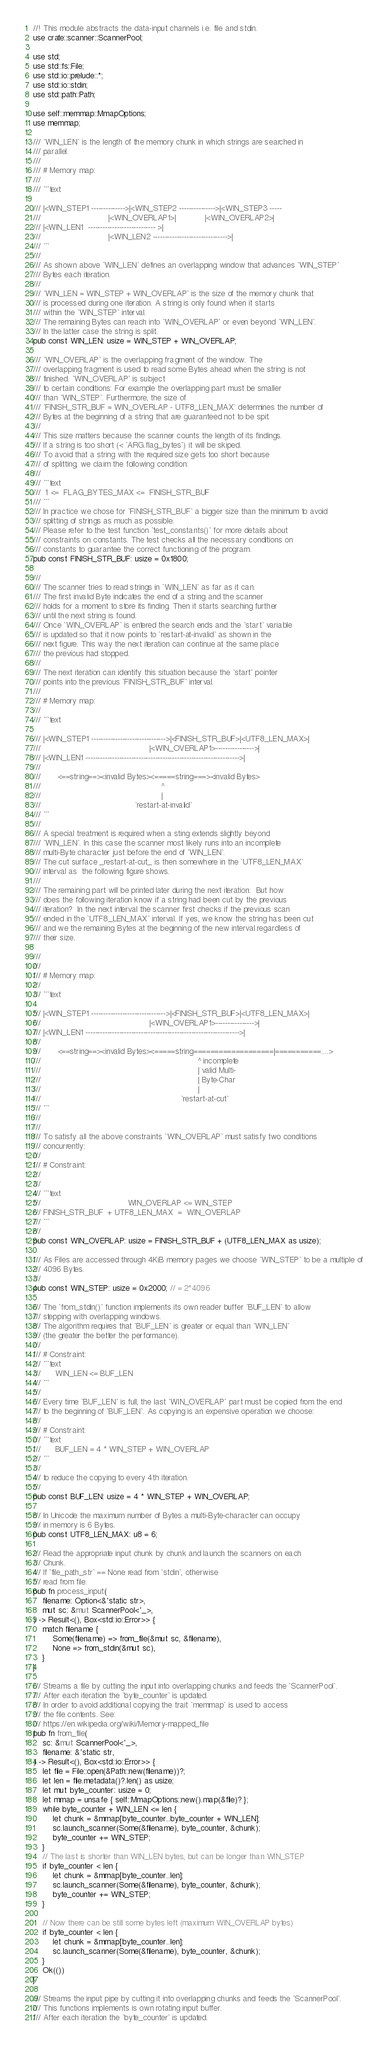<code> <loc_0><loc_0><loc_500><loc_500><_Rust_>//! This module abstracts the data-input channels i.e. file and stdin.
use crate::scanner::ScannerPool;

use std;
use std::fs::File;
use std::io::prelude::*;
use std::io::stdin;
use std::path::Path;

use self::memmap::MmapOptions;
use memmap;

/// `WIN_LEN` is the length of the memory chunk in which strings are searched in
/// parallel.
///
/// # Memory map:
///
/// ```text

/// |<WIN_STEP1 -------------->|<WIN_STEP2 --------------->|<WIN_STEP3 -----
///                            |<WIN_OVERLAP1>|            |<WIN_OVERLAP2>|
/// |<WIN_LEN1  ---------------------------- >|
///                            |<WIN_LEN2 ------------------------------->|
/// ```
///
/// As shown above `WIN_LEN` defines an overlapping window that advances `WIN_STEP`
/// Bytes each iteration.
///
/// `WIN_LEN = WIN_STEP + WIN_OVERLAP` is the size of the memory chunk that
/// is processed during one iteration. A string is only found when it starts
/// within the `WIN_STEP` interval.
/// The remaining Bytes can reach into `WIN_OVERLAP` or even beyond `WIN_LEN`.
/// In the latter case the string is split.
pub const WIN_LEN: usize = WIN_STEP + WIN_OVERLAP;

/// `WIN_OVERLAP` is the overlapping fragment of the window. The
/// overlapping fragment is used to read some Bytes ahead when the string is not
/// finished. `WIN_OVERLAP` is subject
/// to certain conditions: For example the overlapping part must be smaller
/// than `WIN_STEP`. Furthermore, the size of
/// `FINISH_STR_BUF = WIN_OVERLAP - UTF8_LEN_MAX` determines the number of
/// Bytes at the beginning of a string that are guaranteed not to be spit.
///
/// This size matters because the scanner counts the length of its findings.
/// If a string is too short (< `ARG.flag_bytes`) it will be skiped.
/// To avoid that a string with the required size gets too short because
/// of splitting, we claim the following condition:
///
/// ```text
///  1 <=  FLAG_BYTES_MAX <=  FINISH_STR_BUF
/// ```
/// In practice we chose for `FINISH_STR_BUF` a bigger size than the minimum to avoid
/// splitting of strings as much as possible.
/// Please refer to the test function `test_constants()` for more details about
/// constraints on constants. The test checks all the necessary conditions on
/// constants to guarantee the correct functioning of the program.
pub const FINISH_STR_BUF: usize = 0x1800;

///
/// The scanner tries to read strings in `WIN_LEN` as far as it can.
/// The first invalid Byte indicates the end of a string and the scanner
/// holds for a moment to store its finding. Then it starts searching further
/// until the next string is found.
/// Once `WIN_OVERLAP` is entered the search ends and the `start` variable
/// is updated so that it now points to `restart-at-invalid` as shown in the
/// next figure. This way the next iteration can continue at the same place
/// the previous had stopped.
///
/// The next iteration can identify this situation because the `start` pointer
/// points into the previous `FINISH_STR_BUF` interval.
///
/// # Memory map:
///
/// ```text

/// |<WIN_STEP1 ------------------------------->|<FINISH_STR_BUF>|<UTF8_LEN_MAX>|
///                                             |<WIN_OVERLAP1>---------------->|
/// |<WIN_LEN1 ---------------------------------------------------------------->|
///
///       <==string==><invalid Bytes><=====string===><invalid Bytes>
///                                                  ^
///                                                  |
///                                       `restart-at-invalid`
/// ```
///
/// A special treatment is required when a sting extends slightly beyond
/// `WIN_LEN`. In this case the scanner most likely runs into an incomplete
/// multi-Byte character just before the end of `WIN_LEN`.
/// The cut surface _restart-at-cut_ is then somewhere in the `UTF8_LEN_MAX`
/// interval as  the following figure shows.
///
/// The remaining part will be printed later during the next iteration.  But how
/// does the following iteration know if a string had been cut by the previous
/// iteration?  In the next interval the scanner first checks if the previous scan
/// ended in the `UTF8_LEN_MAX` interval. If yes, we know the string has been cut
/// and we the remaining Bytes at the beginning of the new interval regardless of
/// their size.

///
///
/// # Memory map:
///
/// ```text

/// |<WIN_STEP1 ------------------------------->|<FINISH_STR_BUF>|<UTF8_LEN_MAX>|
///                                             |<WIN_OVERLAP1>---------------->|
/// |<WIN_LEN1 ---------------------------------------------------------------->|
///
///       <==string==><invalid Bytes><=====string===================|===========....>
///                                                                 ^ incomplete
///                                                                 | valid Multi-
///                                                                 | Byte-Char
///                                                                 |
///                                                          `restart-at-cut`
/// ```
///
///
/// To satisfy all the above constraints `WIN_OVERLAP` must satisfy two conditions
/// concurrently:
///
/// # Constraint:
///
///
/// ```text
///                                    WIN_OVERLAP <= WIN_STEP
/// FINISH_STR_BUF  + UTF8_LEN_MAX  =  WIN_OVERLAP
/// ```
///
pub const WIN_OVERLAP: usize = FINISH_STR_BUF + (UTF8_LEN_MAX as usize);

/// As Files are accessed through 4KiB memory pages we choose `WIN_STEP` to be a multiple of
/// 4096 Bytes.
///
pub const WIN_STEP: usize = 0x2000; // = 2*4096

/// The `from_stdin()` function implements its own reader buffer `BUF_LEN` to allow
/// stepping with overlapping windows.
/// The algorithm requires that `BUF_LEN` is greater or equal than `WIN_LEN`
/// (the greater the better the performance).
///
/// # Constraint:
/// ```text
///      WIN_LEN <= BUF_LEN
/// ```
///
/// Every time `BUF_LEN` is full, the last `WIN_OVERLAP` part must be copied from the end
/// to the beginning of `BUF_LEN`. As copying is an expensive operation we choose:
///
/// # Constraint:
/// ```text
///      BUF_LEN = 4 * WIN_STEP + WIN_OVERLAP
/// ```
///
/// to reduce the copying to every 4th iteration.
///
pub const BUF_LEN: usize = 4 * WIN_STEP + WIN_OVERLAP;

/// In Unicode the maximum number of Bytes a multi-Byte-character can occupy
/// in memory is 6 Bytes.
pub const UTF8_LEN_MAX: u8 = 6;

/// Read the appropriate input chunk by chunk and launch the scanners on each
/// Chunk.
/// If `file_path_str` == None read from `stdin`, otherwise
/// read from file.
pub fn process_input(
    filename: Option<&'static str>,
    mut sc: &mut ScannerPool<'_>,
) -> Result<(), Box<std::io::Error>> {
    match filename {
        Some(filename) => from_file(&mut sc, &filename),
        None => from_stdin(&mut sc),
    }
}

/// Streams a file by cutting the input into overlapping chunks and feeds the `ScannerPool`.
/// After each iteration the `byte_counter` is updated.
/// In order to avoid additional copying the trait `memmap` is used to access
/// the file contents. See:
/// https://en.wikipedia.org/wiki/Memory-mapped_file
pub fn from_file(
    sc: &mut ScannerPool<'_>,
    filename: &'static str,
) -> Result<(), Box<std::io::Error>> {
    let file = File::open(&Path::new(filename))?;
    let len = file.metadata()?.len() as usize;
    let mut byte_counter: usize = 0;
    let mmap = unsafe { self::MmapOptions::new().map(&file)? };
    while byte_counter + WIN_LEN <= len {
        let chunk = &mmap[byte_counter..byte_counter + WIN_LEN];
        sc.launch_scanner(Some(&filename), byte_counter, &chunk);
        byte_counter += WIN_STEP;
    }
    // The last is shorter than WIN_LEN bytes, but can be longer than WIN_STEP
    if byte_counter < len {
        let chunk = &mmap[byte_counter..len];
        sc.launch_scanner(Some(&filename), byte_counter, &chunk);
        byte_counter += WIN_STEP;
    }

    // Now there can be still some bytes left (maximum WIN_OVERLAP bytes)
    if byte_counter < len {
        let chunk = &mmap[byte_counter..len];
        sc.launch_scanner(Some(&filename), byte_counter, &chunk);
    }
    Ok(())
}

/// Streams the input pipe by cutting it into overlapping chunks and feeds the `ScannerPool`.
/// This functions implements is own rotating input buffer.
/// After each iteration the `byte_counter` is updated.</code> 